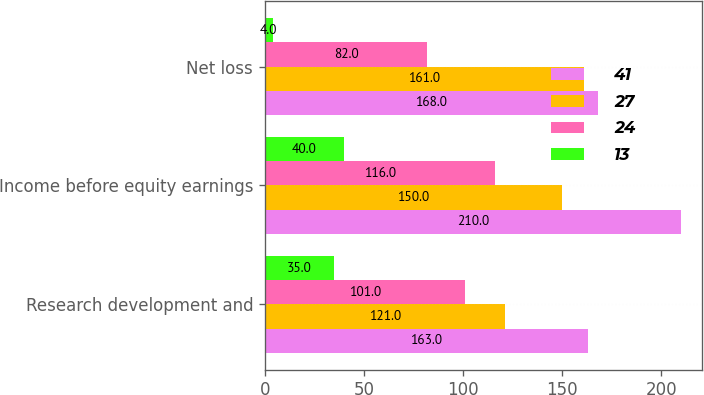Convert chart to OTSL. <chart><loc_0><loc_0><loc_500><loc_500><stacked_bar_chart><ecel><fcel>Research development and<fcel>Income before equity earnings<fcel>Net loss<nl><fcel>41<fcel>163<fcel>210<fcel>168<nl><fcel>27<fcel>121<fcel>150<fcel>161<nl><fcel>24<fcel>101<fcel>116<fcel>82<nl><fcel>13<fcel>35<fcel>40<fcel>4<nl></chart> 